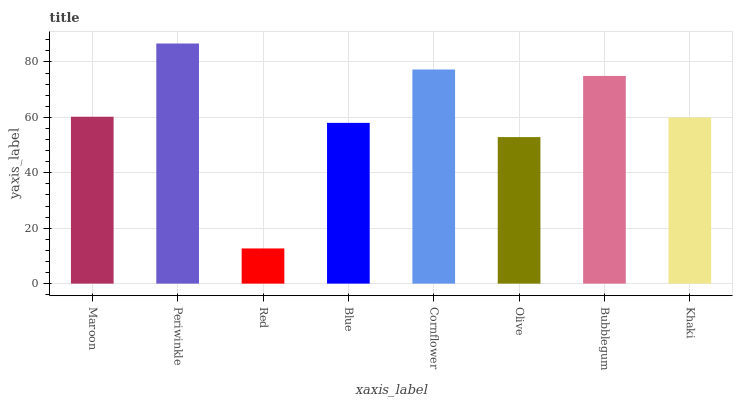Is Red the minimum?
Answer yes or no. Yes. Is Periwinkle the maximum?
Answer yes or no. Yes. Is Periwinkle the minimum?
Answer yes or no. No. Is Red the maximum?
Answer yes or no. No. Is Periwinkle greater than Red?
Answer yes or no. Yes. Is Red less than Periwinkle?
Answer yes or no. Yes. Is Red greater than Periwinkle?
Answer yes or no. No. Is Periwinkle less than Red?
Answer yes or no. No. Is Maroon the high median?
Answer yes or no. Yes. Is Khaki the low median?
Answer yes or no. Yes. Is Red the high median?
Answer yes or no. No. Is Maroon the low median?
Answer yes or no. No. 